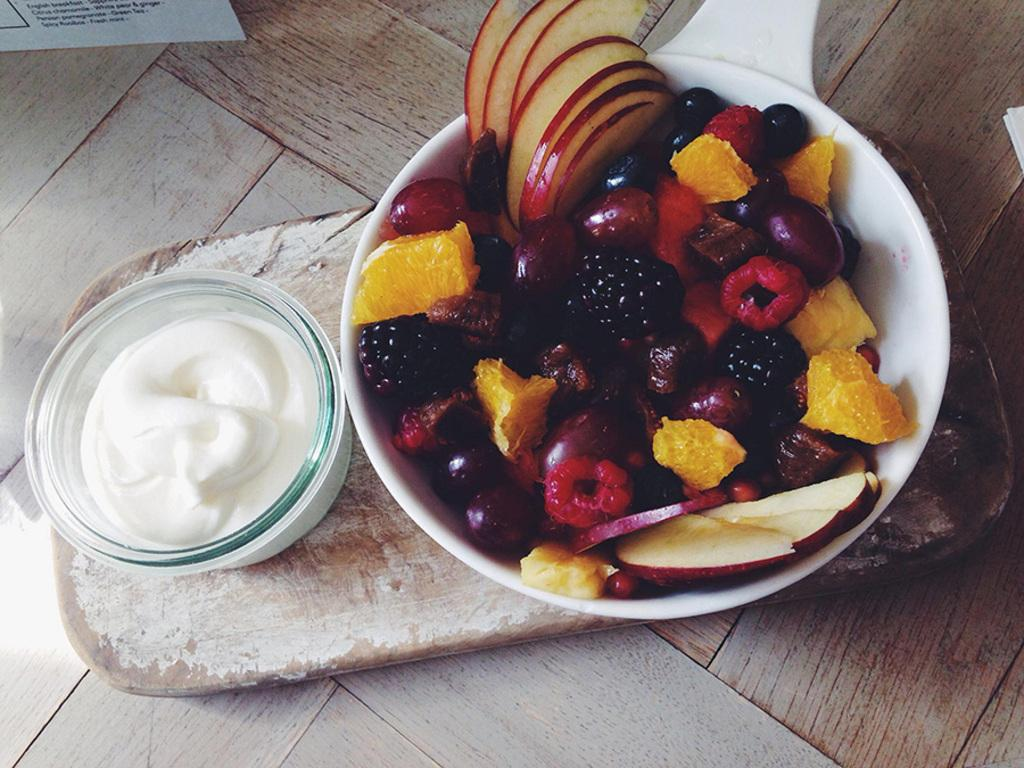What is in the first bowl that is visible in the image? There is a bowl of fruits in the image. What is in the second bowl that is visible in the image? There is a bowl of food items in the image. Where are both bowls placed in the image? Both bowls are placed on a wooden object. How does the language in the image increase the flavor of the food? There is no language present in the image, as it is a visual representation of food items. 